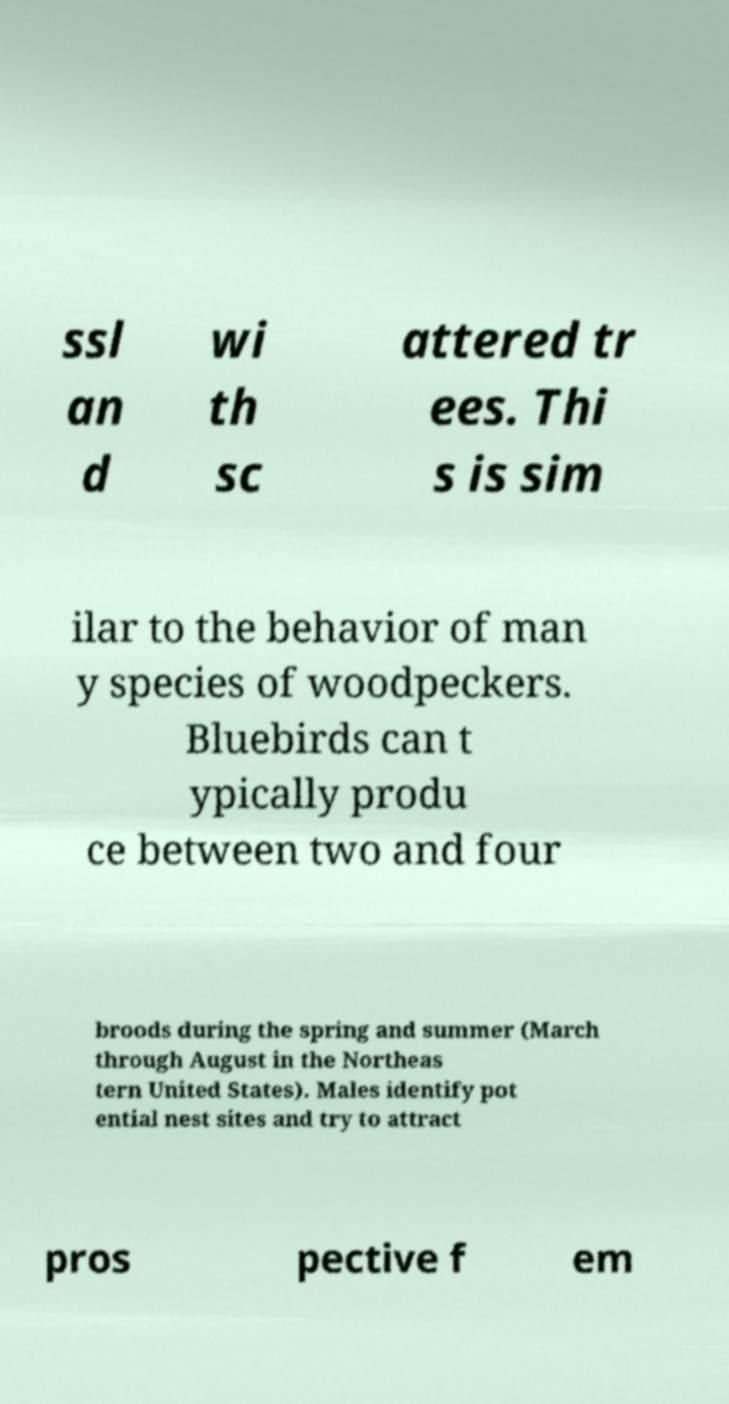Could you extract and type out the text from this image? ssl an d wi th sc attered tr ees. Thi s is sim ilar to the behavior of man y species of woodpeckers. Bluebirds can t ypically produ ce between two and four broods during the spring and summer (March through August in the Northeas tern United States). Males identify pot ential nest sites and try to attract pros pective f em 